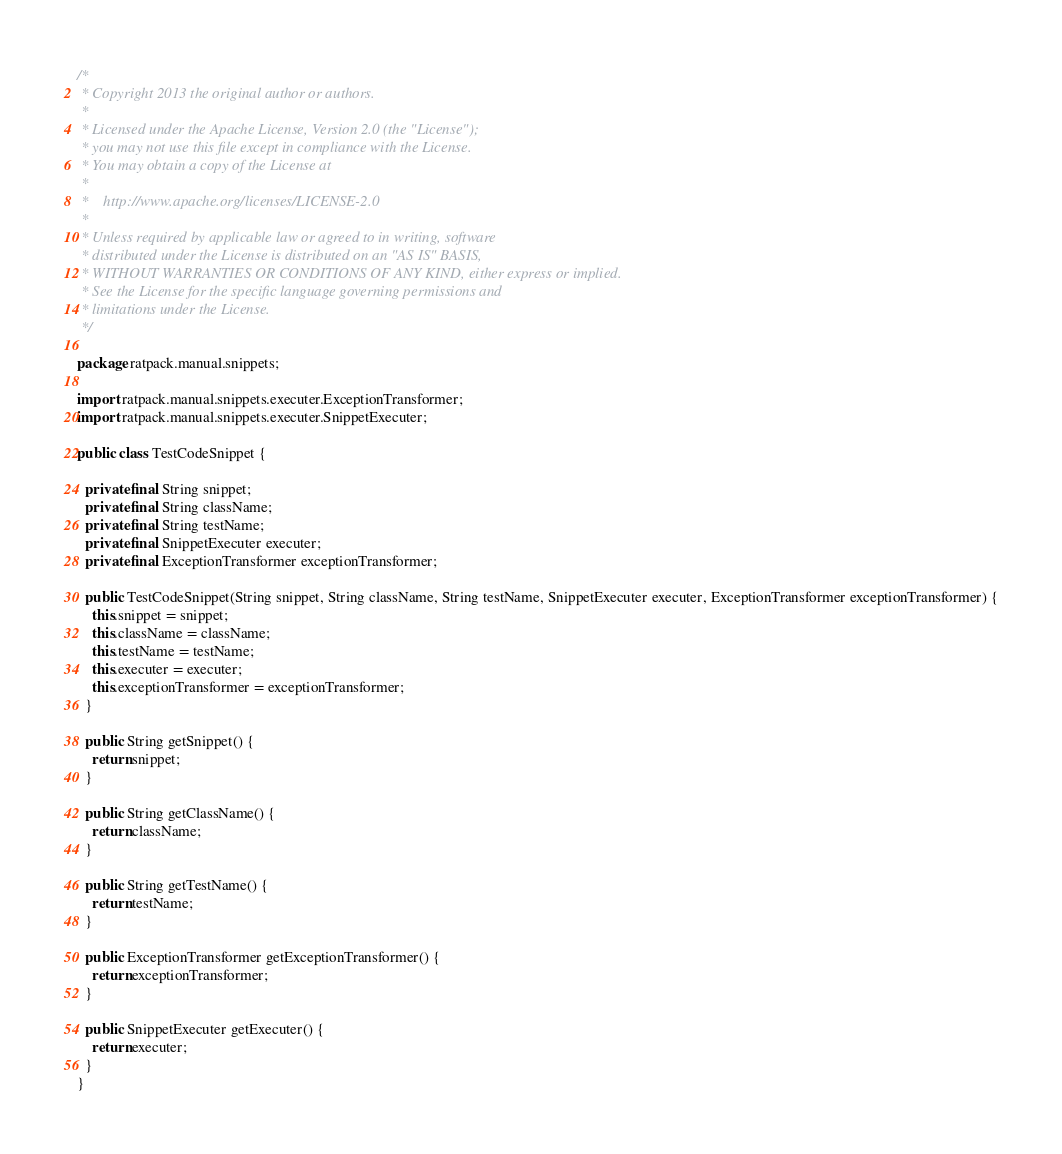Convert code to text. <code><loc_0><loc_0><loc_500><loc_500><_Java_>/*
 * Copyright 2013 the original author or authors.
 *
 * Licensed under the Apache License, Version 2.0 (the "License");
 * you may not use this file except in compliance with the License.
 * You may obtain a copy of the License at
 *
 *    http://www.apache.org/licenses/LICENSE-2.0
 *
 * Unless required by applicable law or agreed to in writing, software
 * distributed under the License is distributed on an "AS IS" BASIS,
 * WITHOUT WARRANTIES OR CONDITIONS OF ANY KIND, either express or implied.
 * See the License for the specific language governing permissions and
 * limitations under the License.
 */

package ratpack.manual.snippets;

import ratpack.manual.snippets.executer.ExceptionTransformer;
import ratpack.manual.snippets.executer.SnippetExecuter;

public class TestCodeSnippet {

  private final String snippet;
  private final String className;
  private final String testName;
  private final SnippetExecuter executer;
  private final ExceptionTransformer exceptionTransformer;

  public TestCodeSnippet(String snippet, String className, String testName, SnippetExecuter executer, ExceptionTransformer exceptionTransformer) {
    this.snippet = snippet;
    this.className = className;
    this.testName = testName;
    this.executer = executer;
    this.exceptionTransformer = exceptionTransformer;
  }

  public String getSnippet() {
    return snippet;
  }

  public String getClassName() {
    return className;
  }

  public String getTestName() {
    return testName;
  }

  public ExceptionTransformer getExceptionTransformer() {
    return exceptionTransformer;
  }

  public SnippetExecuter getExecuter() {
    return executer;
  }
}
</code> 